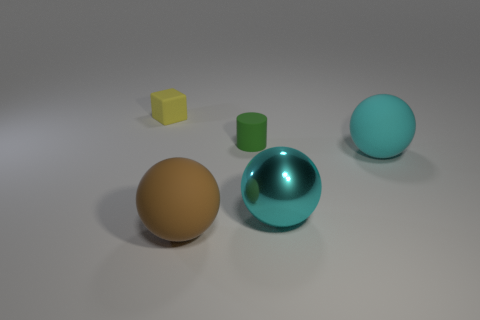Add 3 large green rubber cubes. How many objects exist? 8 Subtract all purple cylinders. Subtract all yellow blocks. How many cylinders are left? 1 Subtract all blue spheres. How many red cylinders are left? 0 Subtract all big cyan metallic cylinders. Subtract all spheres. How many objects are left? 2 Add 2 cyan rubber spheres. How many cyan rubber spheres are left? 3 Add 4 tiny red metallic cylinders. How many tiny red metallic cylinders exist? 4 Subtract all cyan spheres. How many spheres are left? 1 Subtract all large cyan spheres. How many spheres are left? 1 Subtract 1 brown spheres. How many objects are left? 4 Subtract all blocks. How many objects are left? 4 